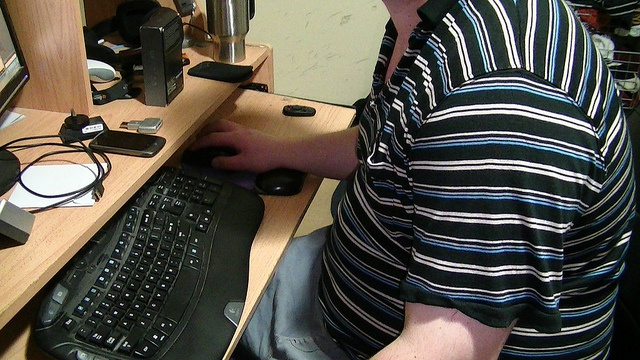Describe the objects in this image and their specific colors. I can see people in black, gray, white, and darkgray tones, keyboard in black, gray, and darkgray tones, cup in black and gray tones, tv in black, gray, and darkgray tones, and cell phone in black and gray tones in this image. 